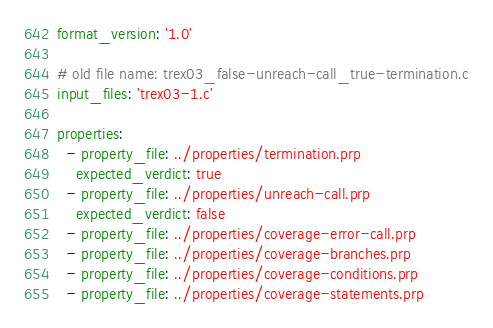Convert code to text. <code><loc_0><loc_0><loc_500><loc_500><_YAML_>format_version: '1.0'

# old file name: trex03_false-unreach-call_true-termination.c
input_files: 'trex03-1.c'

properties:
  - property_file: ../properties/termination.prp
    expected_verdict: true
  - property_file: ../properties/unreach-call.prp
    expected_verdict: false
  - property_file: ../properties/coverage-error-call.prp
  - property_file: ../properties/coverage-branches.prp
  - property_file: ../properties/coverage-conditions.prp
  - property_file: ../properties/coverage-statements.prp
</code> 